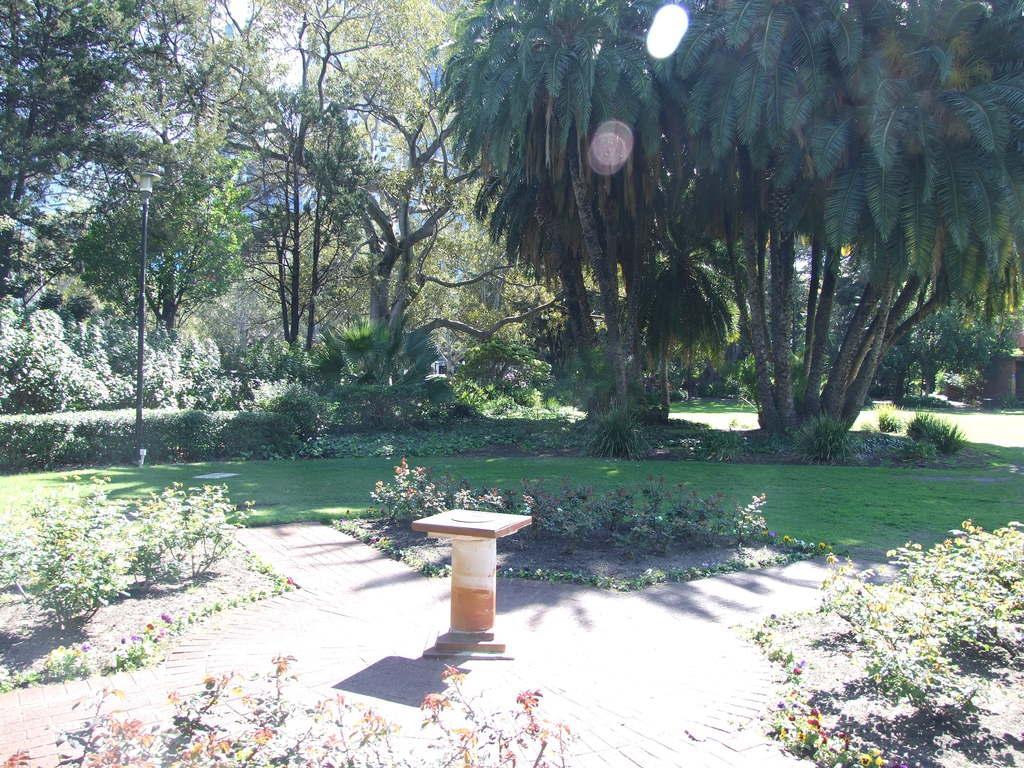How would you summarize this image in a sentence or two? In the middle of the picture, we see a pole. Beside that, we see plants. In the background, we see a lamp pole and there are trees in the background. This picture might be clicked in the garden. It is a sunny day. 